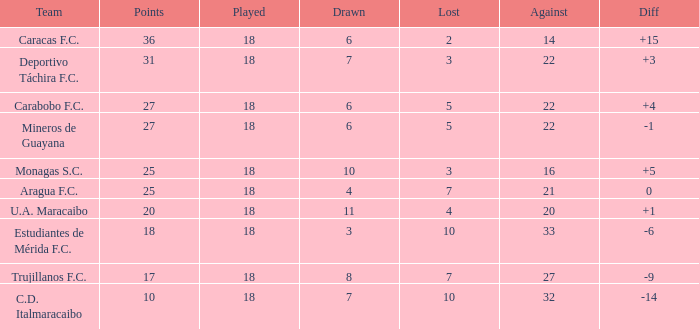What is the minimum score for a team with fewer than 6 draws and under 18 games played? None. 